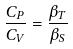Convert formula to latex. <formula><loc_0><loc_0><loc_500><loc_500>\frac { C _ { P } } { C _ { V } } = \frac { \beta _ { T } } { \beta _ { S } }</formula> 